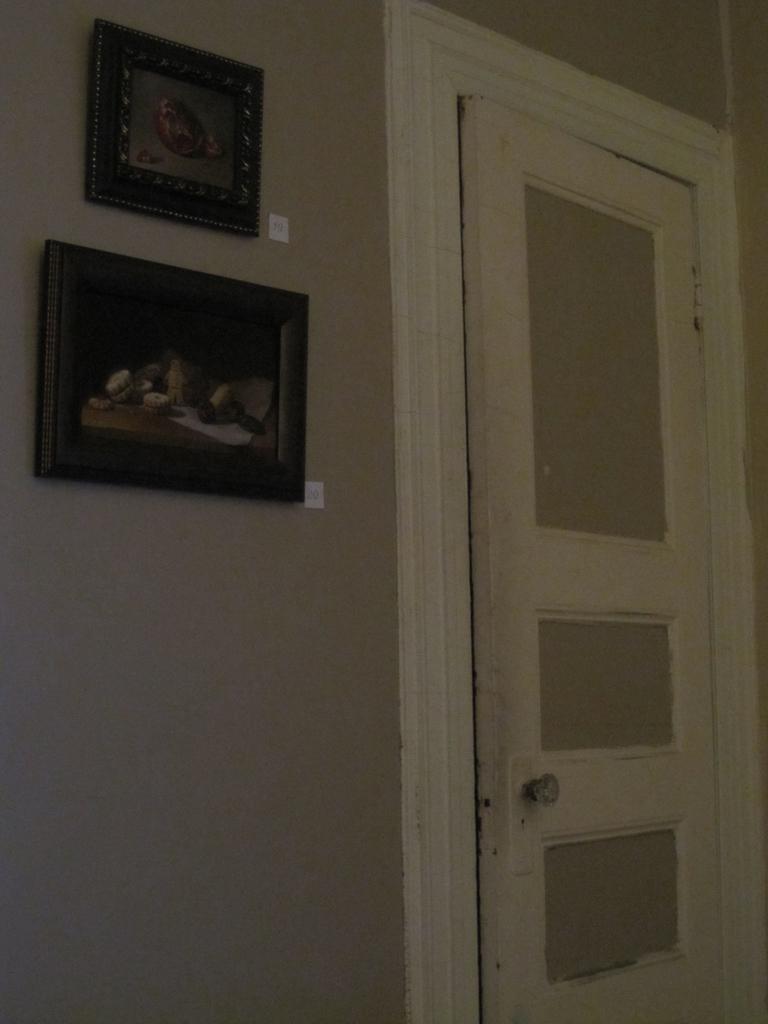Could you give a brief overview of what you see in this image? On the left there is a door. On the right there are frames attached to the wall. 